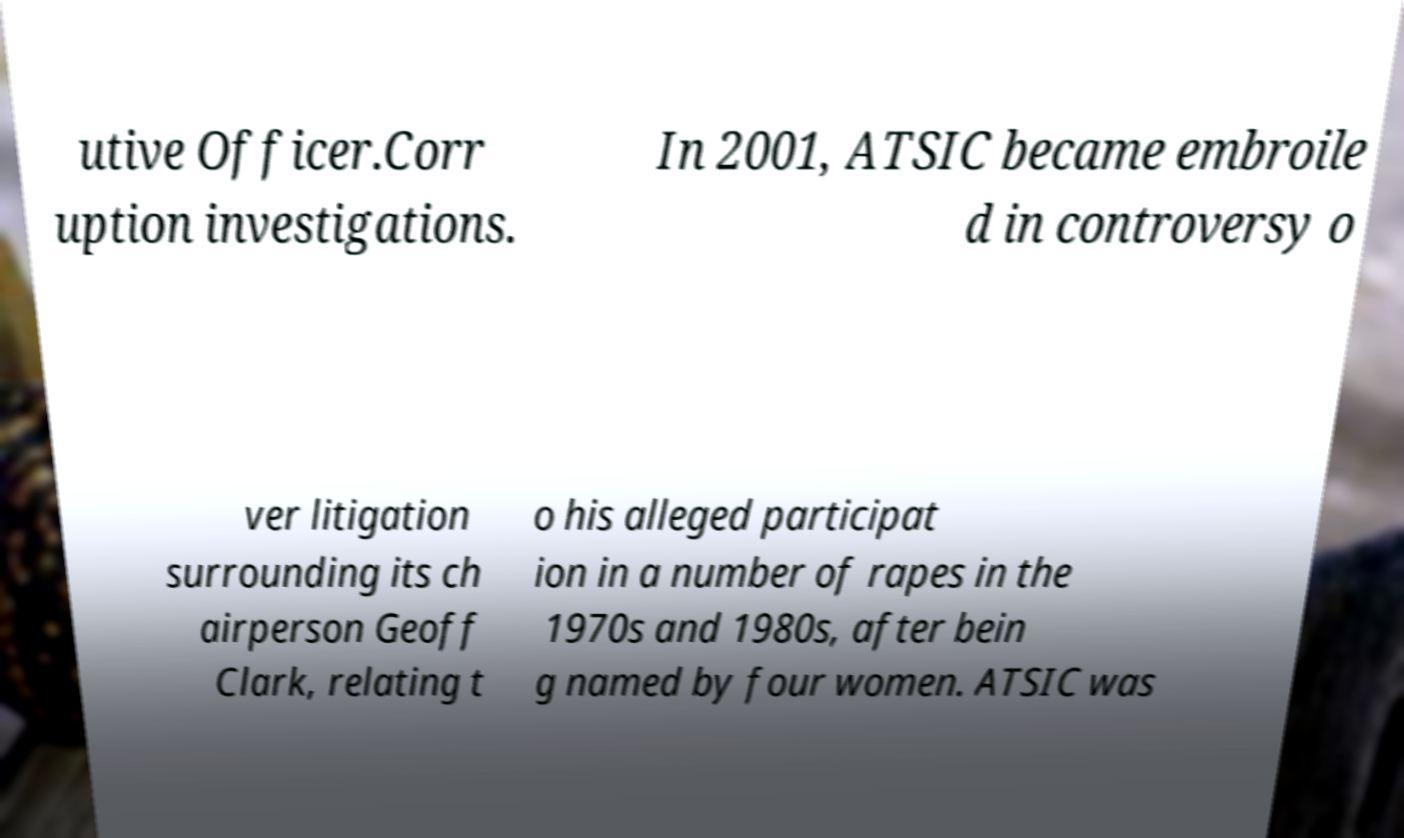I need the written content from this picture converted into text. Can you do that? utive Officer.Corr uption investigations. In 2001, ATSIC became embroile d in controversy o ver litigation surrounding its ch airperson Geoff Clark, relating t o his alleged participat ion in a number of rapes in the 1970s and 1980s, after bein g named by four women. ATSIC was 